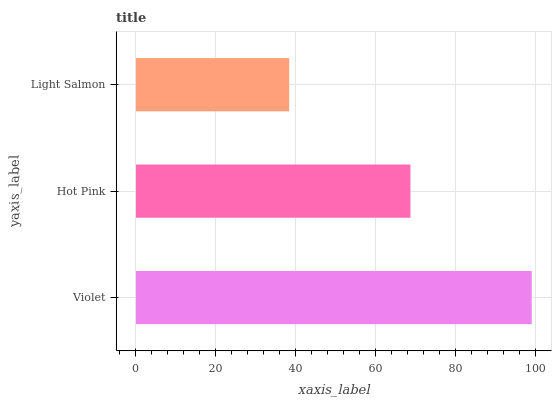Is Light Salmon the minimum?
Answer yes or no. Yes. Is Violet the maximum?
Answer yes or no. Yes. Is Hot Pink the minimum?
Answer yes or no. No. Is Hot Pink the maximum?
Answer yes or no. No. Is Violet greater than Hot Pink?
Answer yes or no. Yes. Is Hot Pink less than Violet?
Answer yes or no. Yes. Is Hot Pink greater than Violet?
Answer yes or no. No. Is Violet less than Hot Pink?
Answer yes or no. No. Is Hot Pink the high median?
Answer yes or no. Yes. Is Hot Pink the low median?
Answer yes or no. Yes. Is Light Salmon the high median?
Answer yes or no. No. Is Violet the low median?
Answer yes or no. No. 